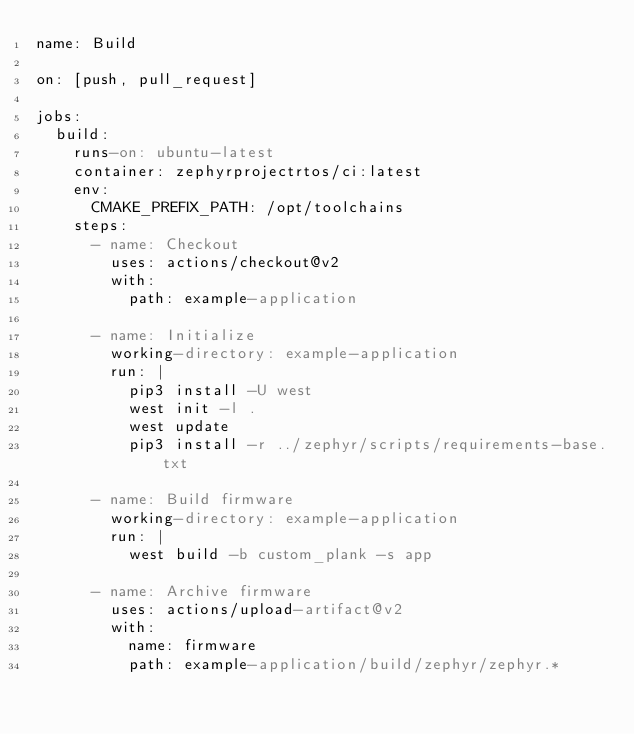<code> <loc_0><loc_0><loc_500><loc_500><_YAML_>name: Build

on: [push, pull_request]

jobs:
  build:
    runs-on: ubuntu-latest
    container: zephyrprojectrtos/ci:latest
    env:
      CMAKE_PREFIX_PATH: /opt/toolchains
    steps:
      - name: Checkout
        uses: actions/checkout@v2
        with:
          path: example-application

      - name: Initialize
        working-directory: example-application
        run: |
          pip3 install -U west
          west init -l .
          west update
          pip3 install -r ../zephyr/scripts/requirements-base.txt

      - name: Build firmware
        working-directory: example-application
        run: |
          west build -b custom_plank -s app

      - name: Archive firmware
        uses: actions/upload-artifact@v2
        with:
          name: firmware
          path: example-application/build/zephyr/zephyr.*
</code> 